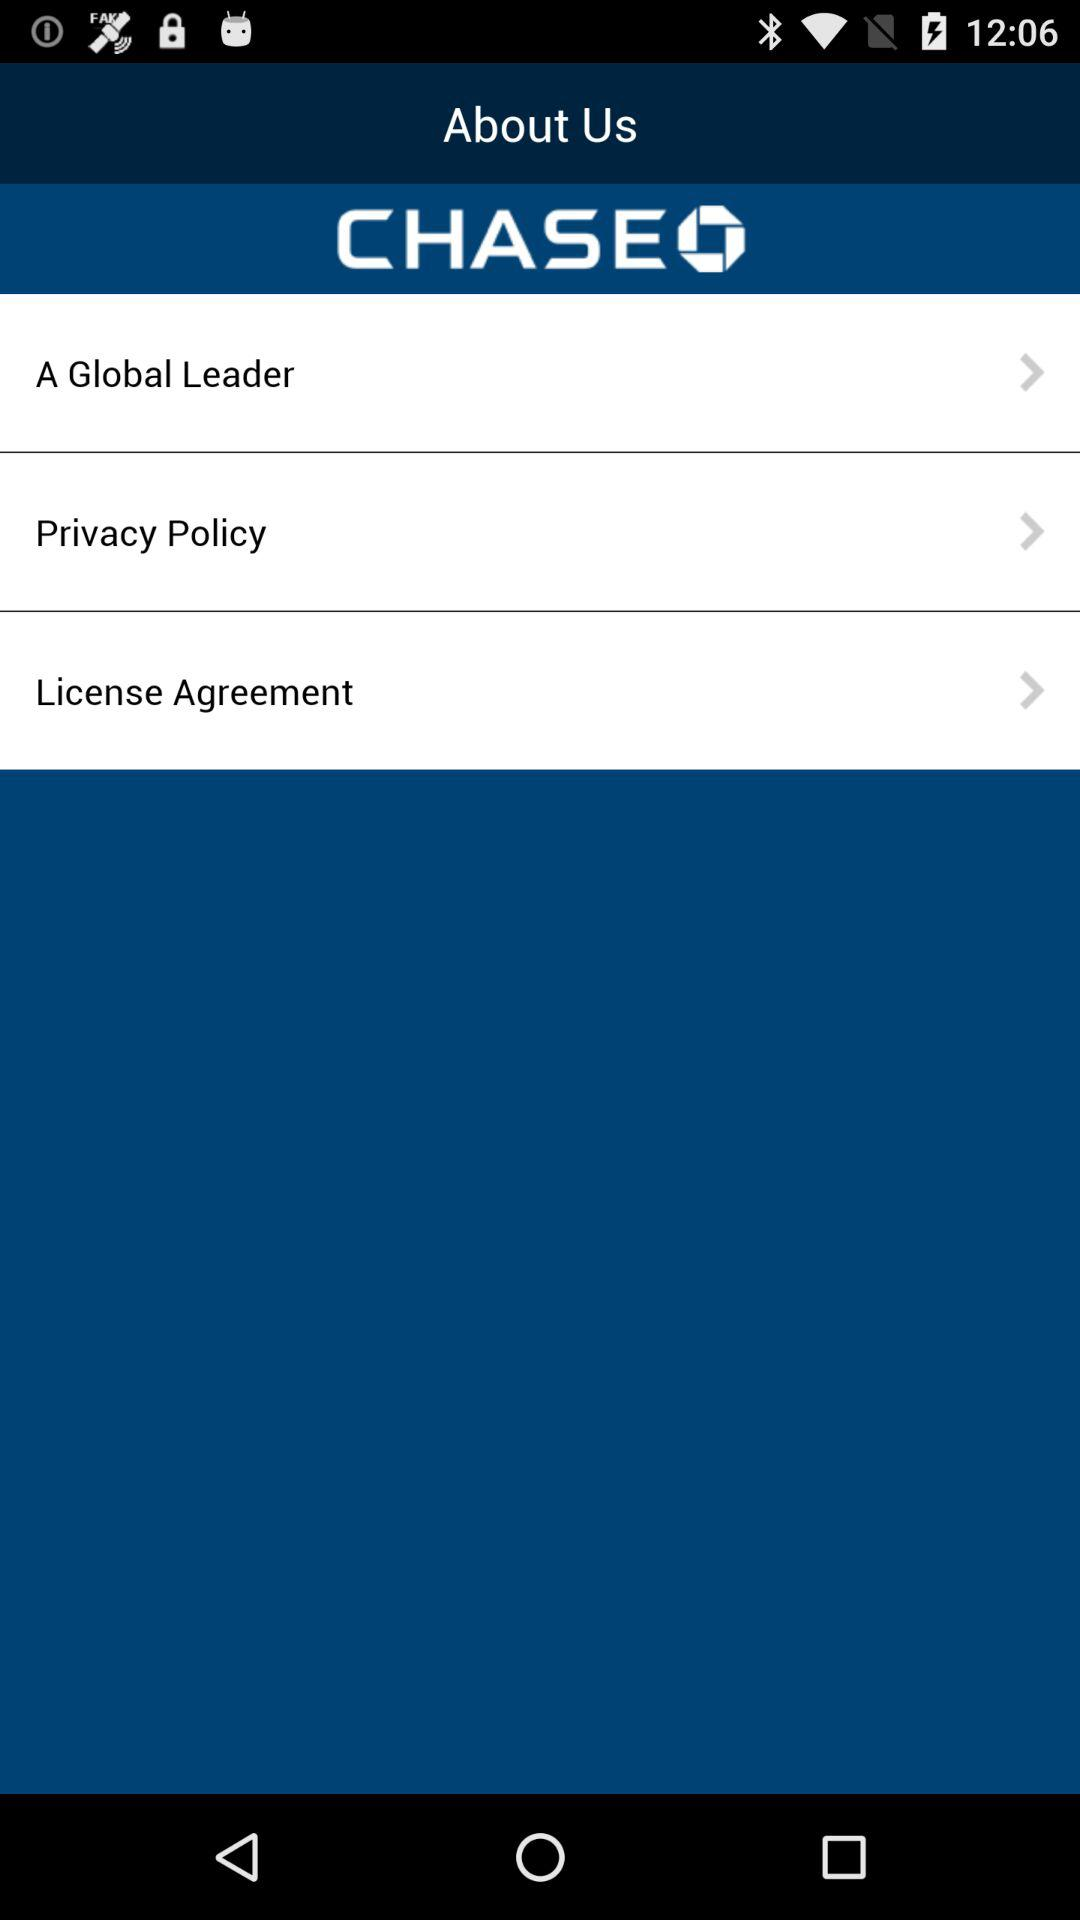Has the user agreed to the privacy policy?
When the provided information is insufficient, respond with <no answer>. <no answer> 